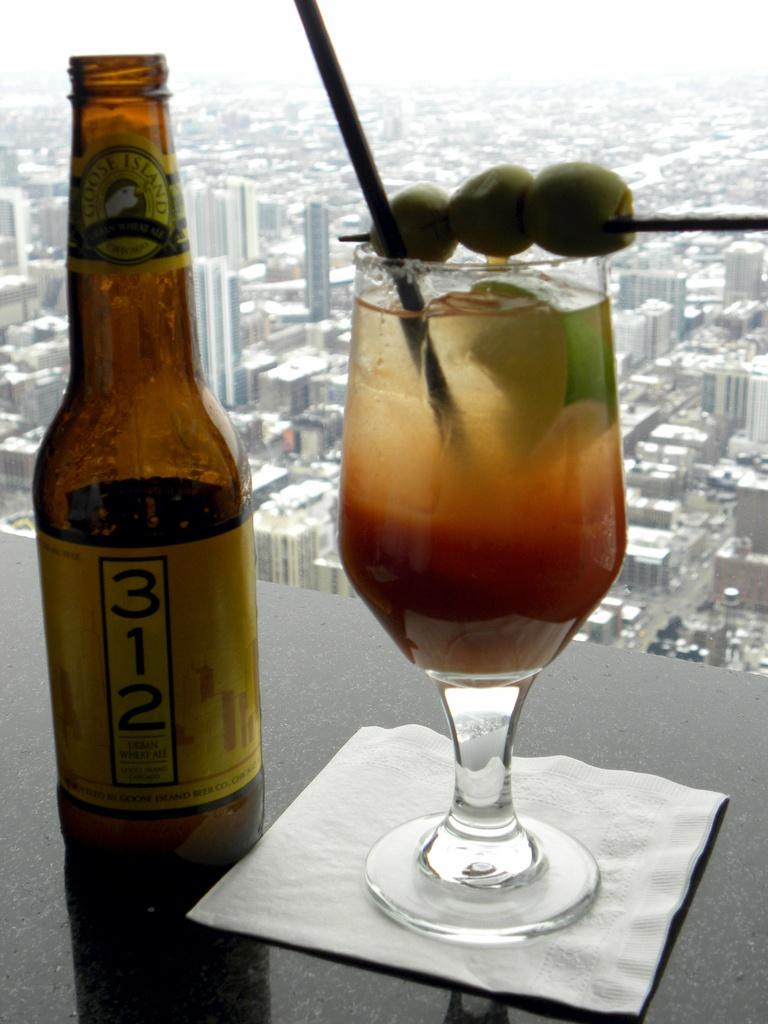<image>
Render a clear and concise summary of the photo. A bottle of Goose Island 312 label sits on table next to a mixed drink on a napkin by a window overlooking a city. 